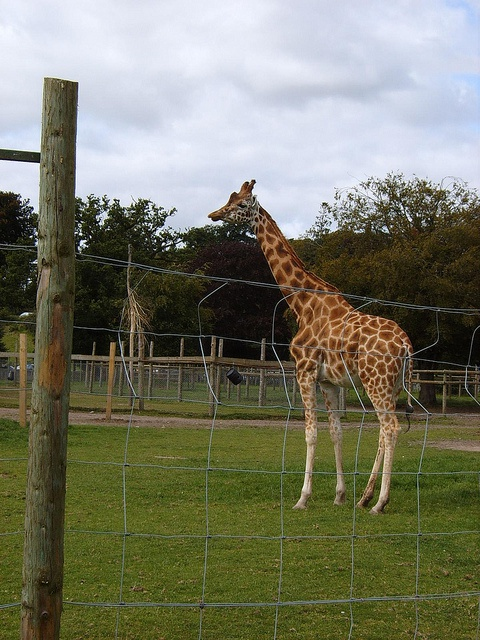Describe the objects in this image and their specific colors. I can see a giraffe in lavender, maroon, gray, and tan tones in this image. 